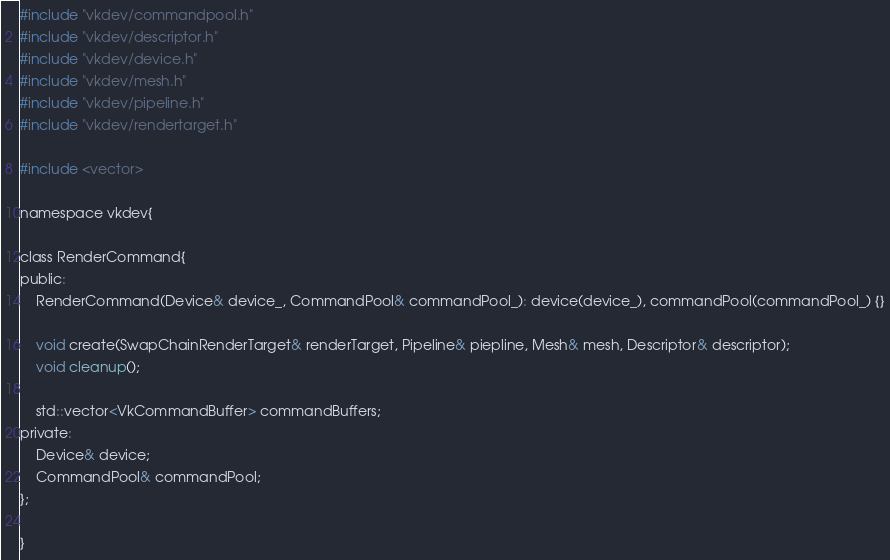Convert code to text. <code><loc_0><loc_0><loc_500><loc_500><_C_>
#include "vkdev/commandpool.h"
#include "vkdev/descriptor.h"
#include "vkdev/device.h"
#include "vkdev/mesh.h"
#include "vkdev/pipeline.h"
#include "vkdev/rendertarget.h"

#include <vector>

namespace vkdev{

class RenderCommand{
public:
    RenderCommand(Device& device_, CommandPool& commandPool_): device(device_), commandPool(commandPool_) {}

    void create(SwapChainRenderTarget& renderTarget, Pipeline& piepline, Mesh& mesh, Descriptor& descriptor);
    void cleanup();

    std::vector<VkCommandBuffer> commandBuffers;
private:
    Device& device;
    CommandPool& commandPool;
};

}
</code> 